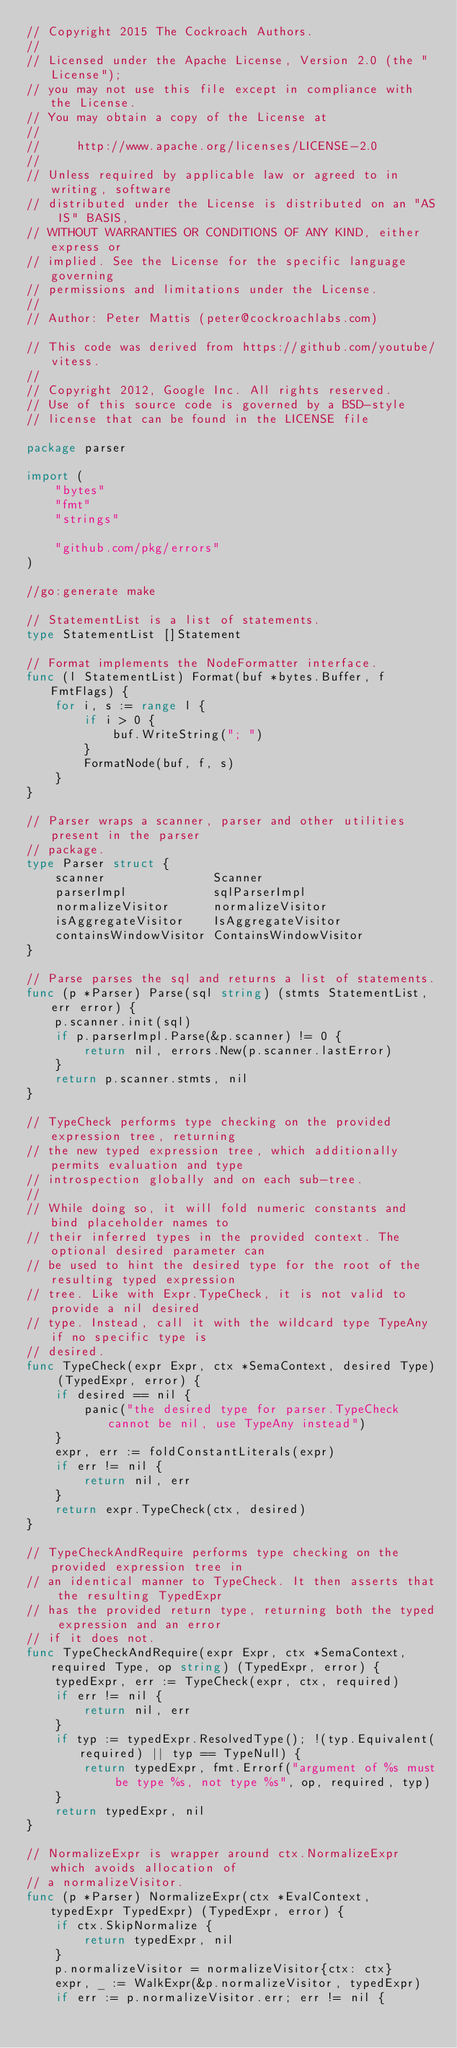<code> <loc_0><loc_0><loc_500><loc_500><_Go_>// Copyright 2015 The Cockroach Authors.
//
// Licensed under the Apache License, Version 2.0 (the "License");
// you may not use this file except in compliance with the License.
// You may obtain a copy of the License at
//
//     http://www.apache.org/licenses/LICENSE-2.0
//
// Unless required by applicable law or agreed to in writing, software
// distributed under the License is distributed on an "AS IS" BASIS,
// WITHOUT WARRANTIES OR CONDITIONS OF ANY KIND, either express or
// implied. See the License for the specific language governing
// permissions and limitations under the License.
//
// Author: Peter Mattis (peter@cockroachlabs.com)

// This code was derived from https://github.com/youtube/vitess.
//
// Copyright 2012, Google Inc. All rights reserved.
// Use of this source code is governed by a BSD-style
// license that can be found in the LICENSE file

package parser

import (
	"bytes"
	"fmt"
	"strings"

	"github.com/pkg/errors"
)

//go:generate make

// StatementList is a list of statements.
type StatementList []Statement

// Format implements the NodeFormatter interface.
func (l StatementList) Format(buf *bytes.Buffer, f FmtFlags) {
	for i, s := range l {
		if i > 0 {
			buf.WriteString("; ")
		}
		FormatNode(buf, f, s)
	}
}

// Parser wraps a scanner, parser and other utilities present in the parser
// package.
type Parser struct {
	scanner               Scanner
	parserImpl            sqlParserImpl
	normalizeVisitor      normalizeVisitor
	isAggregateVisitor    IsAggregateVisitor
	containsWindowVisitor ContainsWindowVisitor
}

// Parse parses the sql and returns a list of statements.
func (p *Parser) Parse(sql string) (stmts StatementList, err error) {
	p.scanner.init(sql)
	if p.parserImpl.Parse(&p.scanner) != 0 {
		return nil, errors.New(p.scanner.lastError)
	}
	return p.scanner.stmts, nil
}

// TypeCheck performs type checking on the provided expression tree, returning
// the new typed expression tree, which additionally permits evaluation and type
// introspection globally and on each sub-tree.
//
// While doing so, it will fold numeric constants and bind placeholder names to
// their inferred types in the provided context. The optional desired parameter can
// be used to hint the desired type for the root of the resulting typed expression
// tree. Like with Expr.TypeCheck, it is not valid to provide a nil desired
// type. Instead, call it with the wildcard type TypeAny if no specific type is
// desired.
func TypeCheck(expr Expr, ctx *SemaContext, desired Type) (TypedExpr, error) {
	if desired == nil {
		panic("the desired type for parser.TypeCheck cannot be nil, use TypeAny instead")
	}
	expr, err := foldConstantLiterals(expr)
	if err != nil {
		return nil, err
	}
	return expr.TypeCheck(ctx, desired)
}

// TypeCheckAndRequire performs type checking on the provided expression tree in
// an identical manner to TypeCheck. It then asserts that the resulting TypedExpr
// has the provided return type, returning both the typed expression and an error
// if it does not.
func TypeCheckAndRequire(expr Expr, ctx *SemaContext, required Type, op string) (TypedExpr, error) {
	typedExpr, err := TypeCheck(expr, ctx, required)
	if err != nil {
		return nil, err
	}
	if typ := typedExpr.ResolvedType(); !(typ.Equivalent(required) || typ == TypeNull) {
		return typedExpr, fmt.Errorf("argument of %s must be type %s, not type %s", op, required, typ)
	}
	return typedExpr, nil
}

// NormalizeExpr is wrapper around ctx.NormalizeExpr which avoids allocation of
// a normalizeVisitor.
func (p *Parser) NormalizeExpr(ctx *EvalContext, typedExpr TypedExpr) (TypedExpr, error) {
	if ctx.SkipNormalize {
		return typedExpr, nil
	}
	p.normalizeVisitor = normalizeVisitor{ctx: ctx}
	expr, _ := WalkExpr(&p.normalizeVisitor, typedExpr)
	if err := p.normalizeVisitor.err; err != nil {</code> 